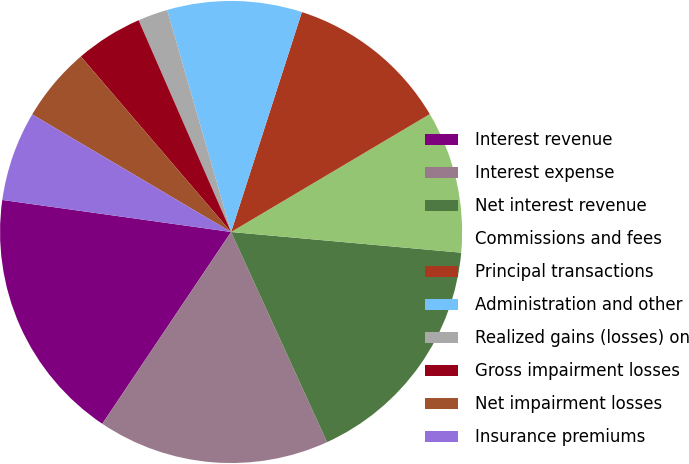<chart> <loc_0><loc_0><loc_500><loc_500><pie_chart><fcel>Interest revenue<fcel>Interest expense<fcel>Net interest revenue<fcel>Commissions and fees<fcel>Principal transactions<fcel>Administration and other<fcel>Realized gains (losses) on<fcel>Gross impairment losses<fcel>Net impairment losses<fcel>Insurance premiums<nl><fcel>17.8%<fcel>16.23%<fcel>16.75%<fcel>9.95%<fcel>11.52%<fcel>9.42%<fcel>2.09%<fcel>4.71%<fcel>5.24%<fcel>6.28%<nl></chart> 